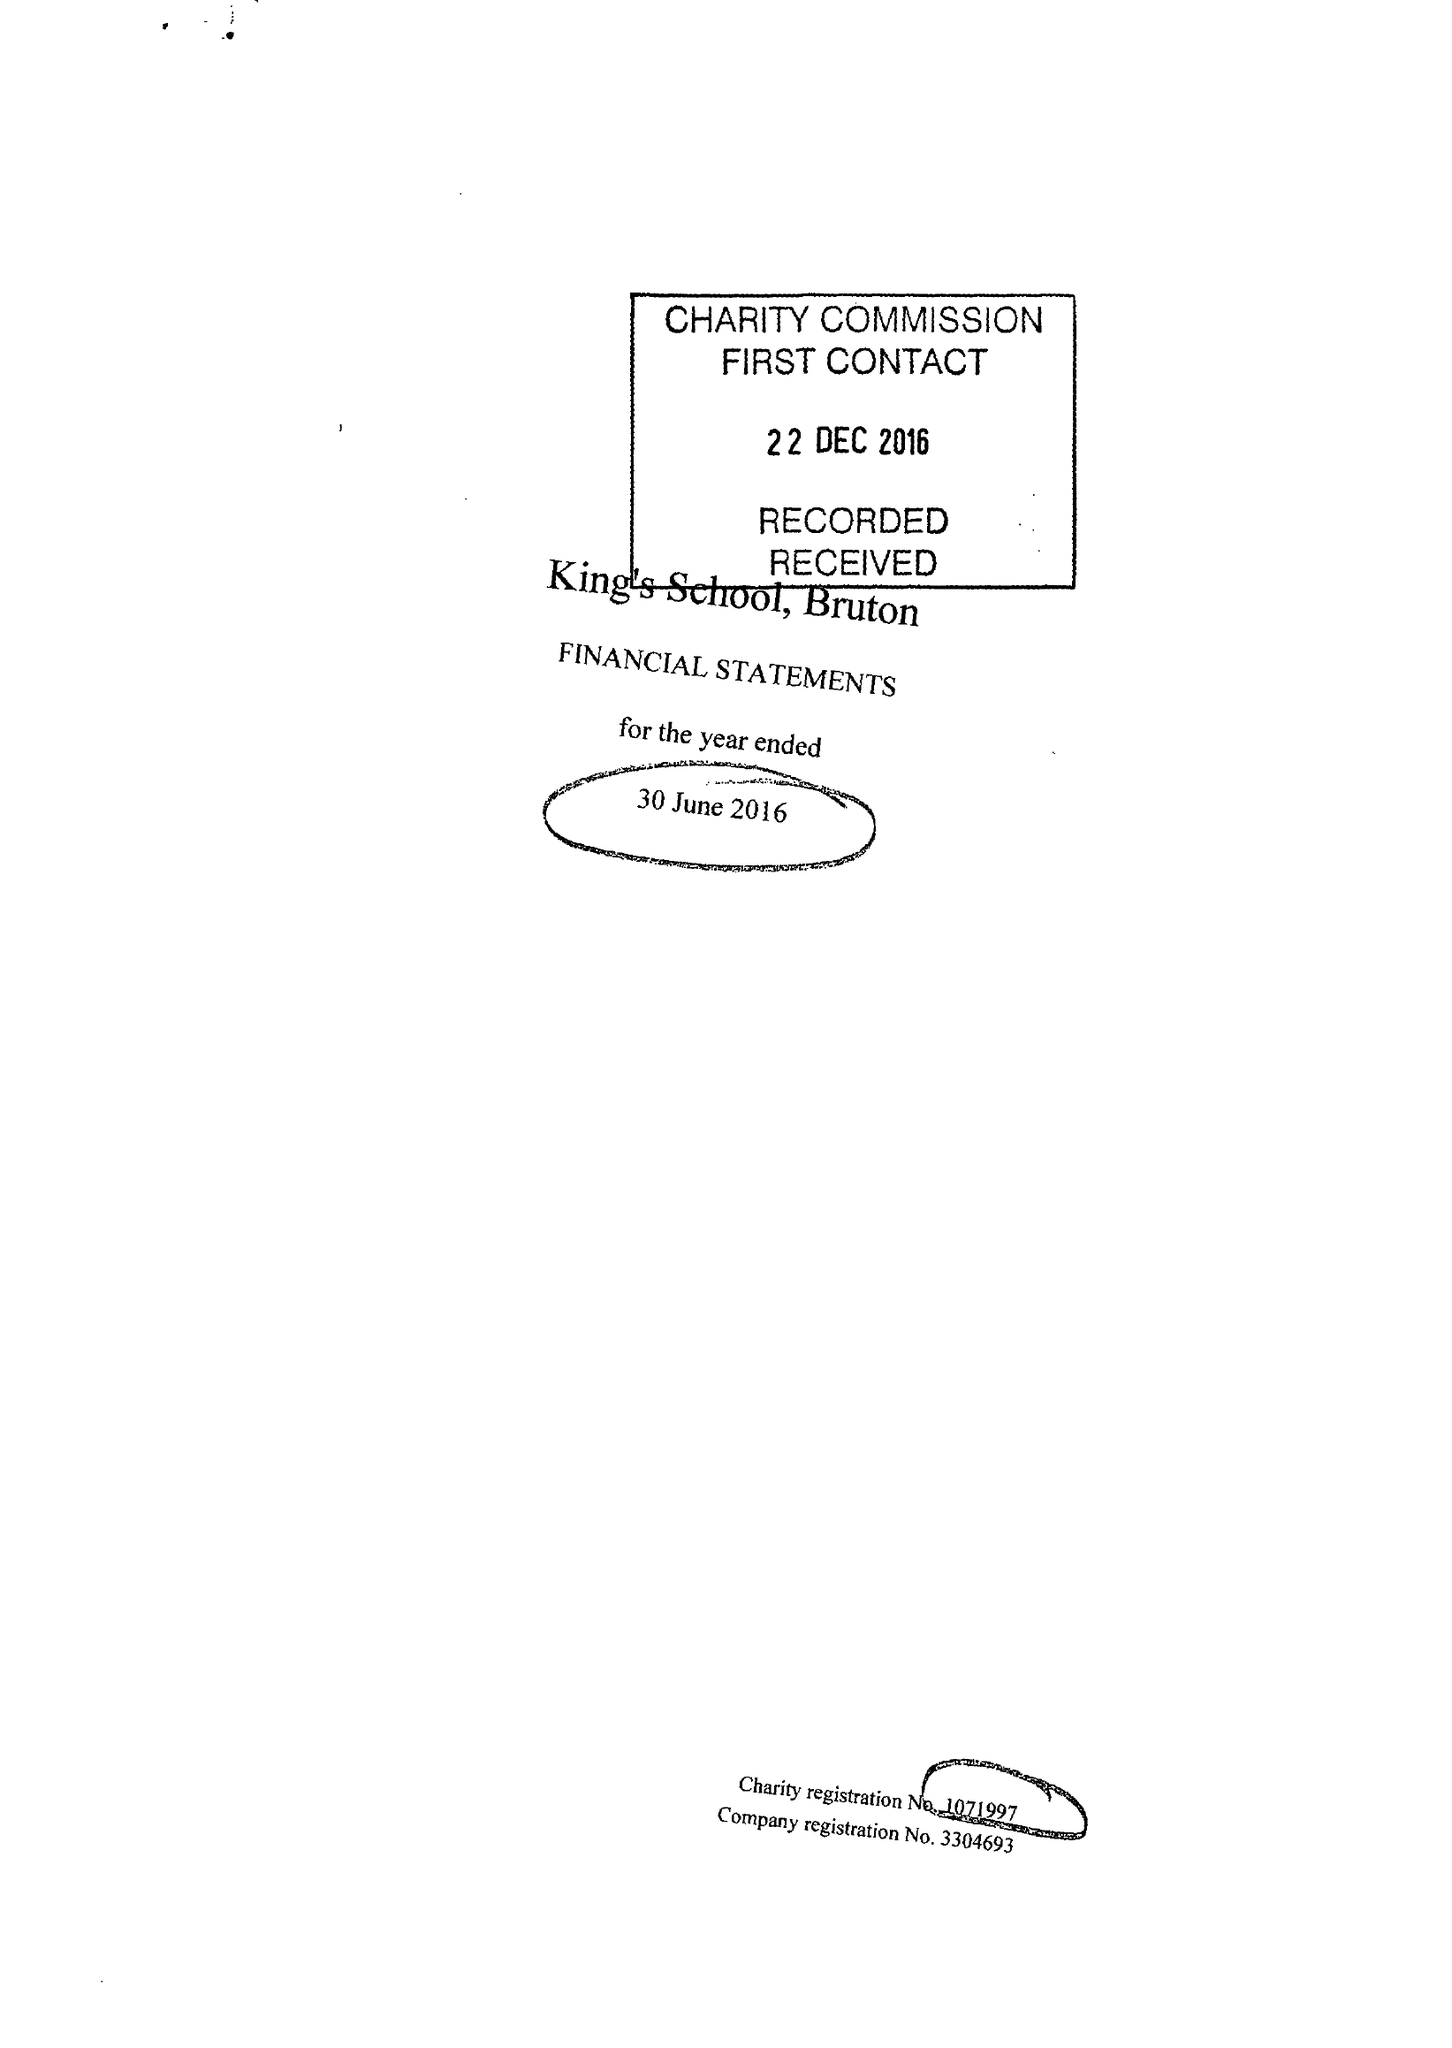What is the value for the charity_name?
Answer the question using a single word or phrase. King's School, Bruton 